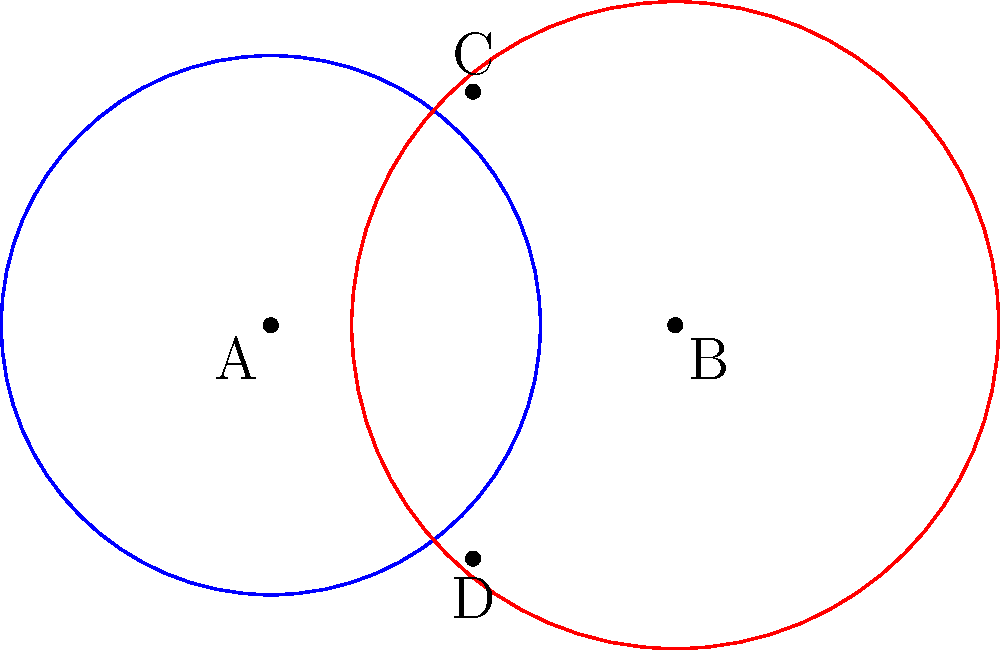In your book project, you want to illustrate the concept of overlapping story arcs using intersecting circles. Circle A represents the main plot, while circle B represents a subplot. If the radius of circle A is 1 unit and the radius of circle B is 1.2 units, and their centers are 1.5 units apart, what is the area of the overlapping region (representing the interaction between the main plot and subplot)? Express your answer in terms of $\pi$. To find the area of the overlapping region, we need to follow these steps:

1) First, we need to find the distance between the intersection points (C and D) of the circles. We can do this using the formula:

   $d = 2\sqrt{\frac{(r_1 + r_2 + a)(r_1 + r_2 - a)(r_2 + a - r_1)(a + r_1 - r_2)}{4a^2}}$

   Where $a$ is the distance between the centers, $r_1$ is the radius of circle A, and $r_2$ is the radius of circle B.

2) Plugging in our values:
   $a = 1.5$, $r_1 = 1$, $r_2 = 1.2$

   $d = 2\sqrt{\frac{(1 + 1.2 + 1.5)(1 + 1.2 - 1.5)(1.2 + 1.5 - 1)(1.5 + 1 - 1.2)}{4(1.5)^2}}$
   $= 2\sqrt{\frac{3.7 \cdot 0.7 \cdot 1.7 \cdot 1.3}{9}} = 1.732$

3) Now we can find the area of the overlapping region using the formula:

   $Area = r_1^2 \arccos(\frac{a^2 + r_1^2 - r_2^2}{2ar_1}) + r_2^2 \arccos(\frac{a^2 + r_2^2 - r_1^2}{2ar_2}) - \frac{1}{2}\sqrt{(-a+r_1+r_2)(a+r_1-r_2)(a-r_1+r_2)(a+r_1+r_2)}$

4) Plugging in our values:

   $Area = 1^2 \arccos(\frac{1.5^2 + 1^2 - 1.2^2}{2 \cdot 1.5 \cdot 1}) + 1.2^2 \arccos(\frac{1.5^2 + 1.2^2 - 1^2}{2 \cdot 1.5 \cdot 1.2}) - \frac{1}{2}\sqrt{(-1.5+1+1.2)(1.5+1-1.2)(1.5-1+1.2)(1.5+1+1.2)}$

5) Simplifying:

   $Area = \arccos(0.3917) + 1.44 \arccos(0.6736) - 0.866$

6) Calculating:

   $Area \approx 1.1781 + 1.1781 - 0.866 = 1.4902$

Therefore, the area of the overlapping region is approximately $1.4902$ square units.
Answer: $\frac{1.4902}{\pi} \pi \approx 0.4743\pi$ square units 